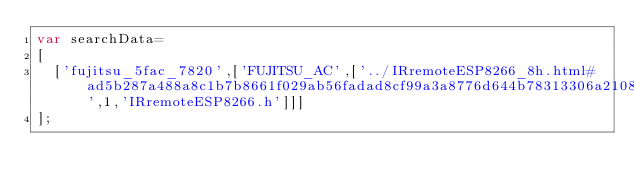<code> <loc_0><loc_0><loc_500><loc_500><_JavaScript_>var searchData=
[
  ['fujitsu_5fac_7820',['FUJITSU_AC',['../IRremoteESP8266_8h.html#ad5b287a488a8c1b7b8661f029ab56fadad8cf99a3a8776d644b78313306a2108c',1,'IRremoteESP8266.h']]]
];
</code> 